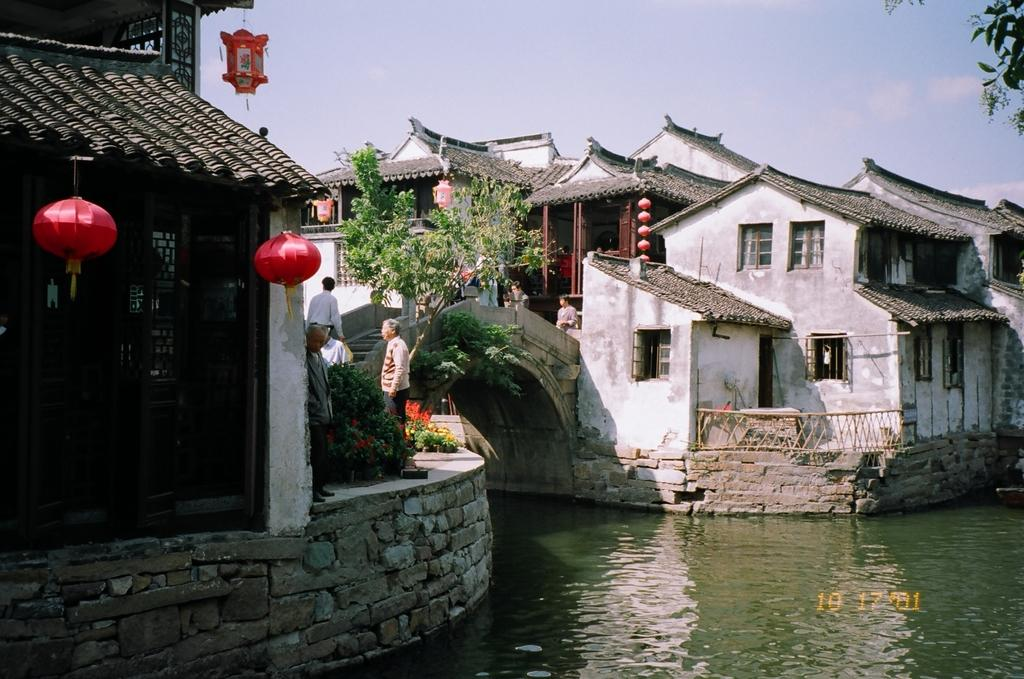What type of structure can be seen in the image? There is a bridge in the image. What else can be seen in the image besides the bridge? There are houses, lamps, plants, people, trees, and the sky visible in the image. Can you describe the lighting in the image? There are lamps in the image, which suggests that there is artificial lighting present. What type of vegetation is visible in the image? There are plants and trees in the image. How many fangs can be seen on the people in the image? There are no fangs visible on the people in the image, as fangs are not a characteristic of humans. What type of car is parked near the bridge in the image? There is no car present in the image; it only features a bridge, houses, lamps, plants, people, trees, and the sky. 